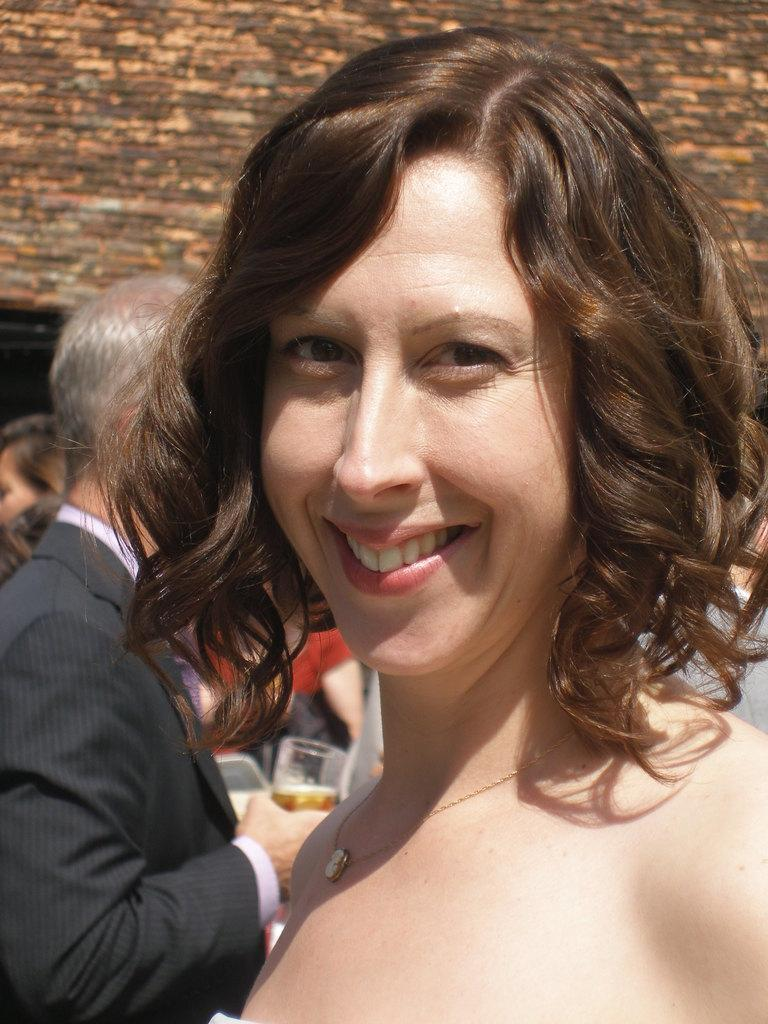Who is the main subject in the image? There is a woman in the image. What is the woman doing in the image? The woman is smiling. Are there any other people visible in the image? Yes, there are other people behind the woman. What can be seen in the background of the image? There is a brick wall in the background of the image. What type of tent is being set up in the image? There is no tent present in the image. What is the woman offering to the people behind her in the image? The image does not show the woman offering anything to the people behind her. 